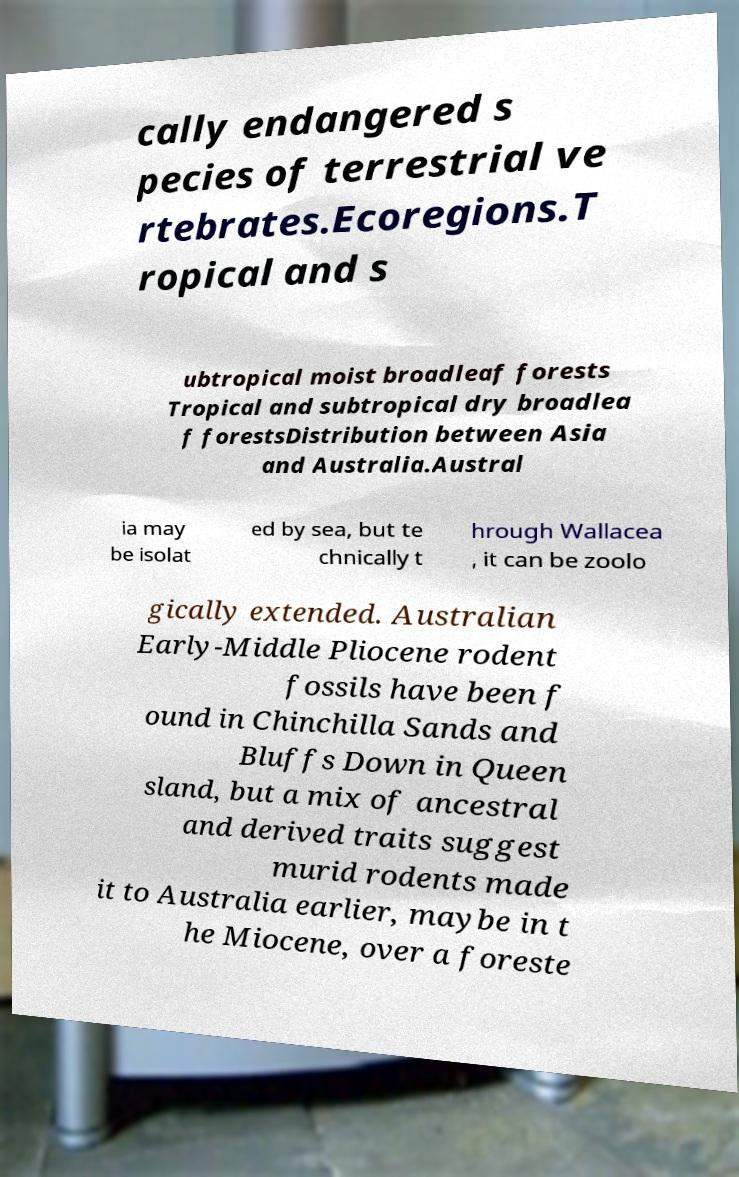I need the written content from this picture converted into text. Can you do that? cally endangered s pecies of terrestrial ve rtebrates.Ecoregions.T ropical and s ubtropical moist broadleaf forests Tropical and subtropical dry broadlea f forestsDistribution between Asia and Australia.Austral ia may be isolat ed by sea, but te chnically t hrough Wallacea , it can be zoolo gically extended. Australian Early-Middle Pliocene rodent fossils have been f ound in Chinchilla Sands and Bluffs Down in Queen sland, but a mix of ancestral and derived traits suggest murid rodents made it to Australia earlier, maybe in t he Miocene, over a foreste 